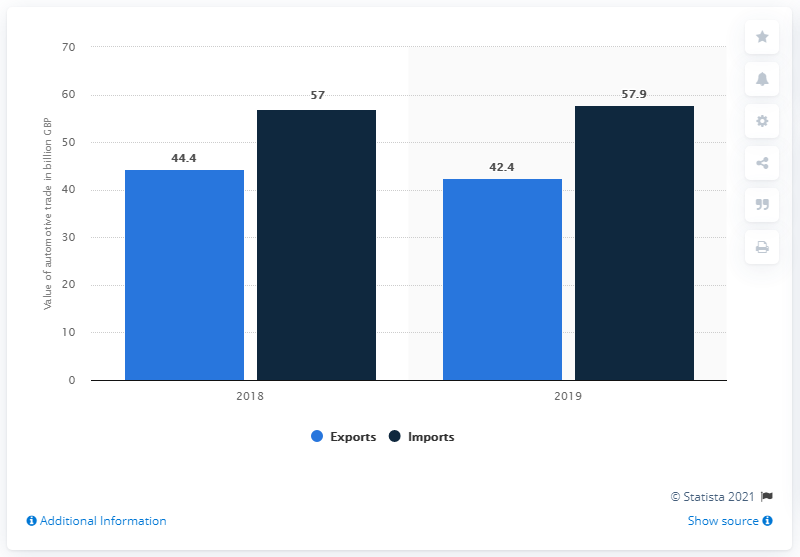Mention a couple of crucial points in this snapshot. The disparity between imports and exports persisted and grew in 2019. In 2019, the value of automotive exports was 42.4 billion US dollars. 